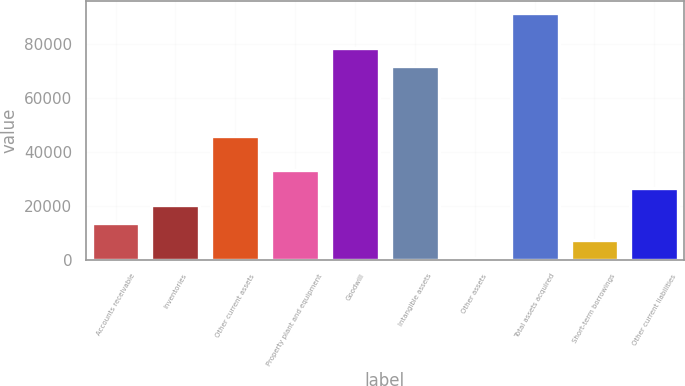Convert chart to OTSL. <chart><loc_0><loc_0><loc_500><loc_500><bar_chart><fcel>Accounts receivable<fcel>Inventories<fcel>Other current assets<fcel>Property plant and equipment<fcel>Goodwill<fcel>Intangible assets<fcel>Other assets<fcel>Total assets acquired<fcel>Short-term borrowings<fcel>Other current liabilities<nl><fcel>13692<fcel>20164.5<fcel>46054.5<fcel>33109.5<fcel>78417<fcel>71944.5<fcel>747<fcel>91362<fcel>7219.5<fcel>26637<nl></chart> 